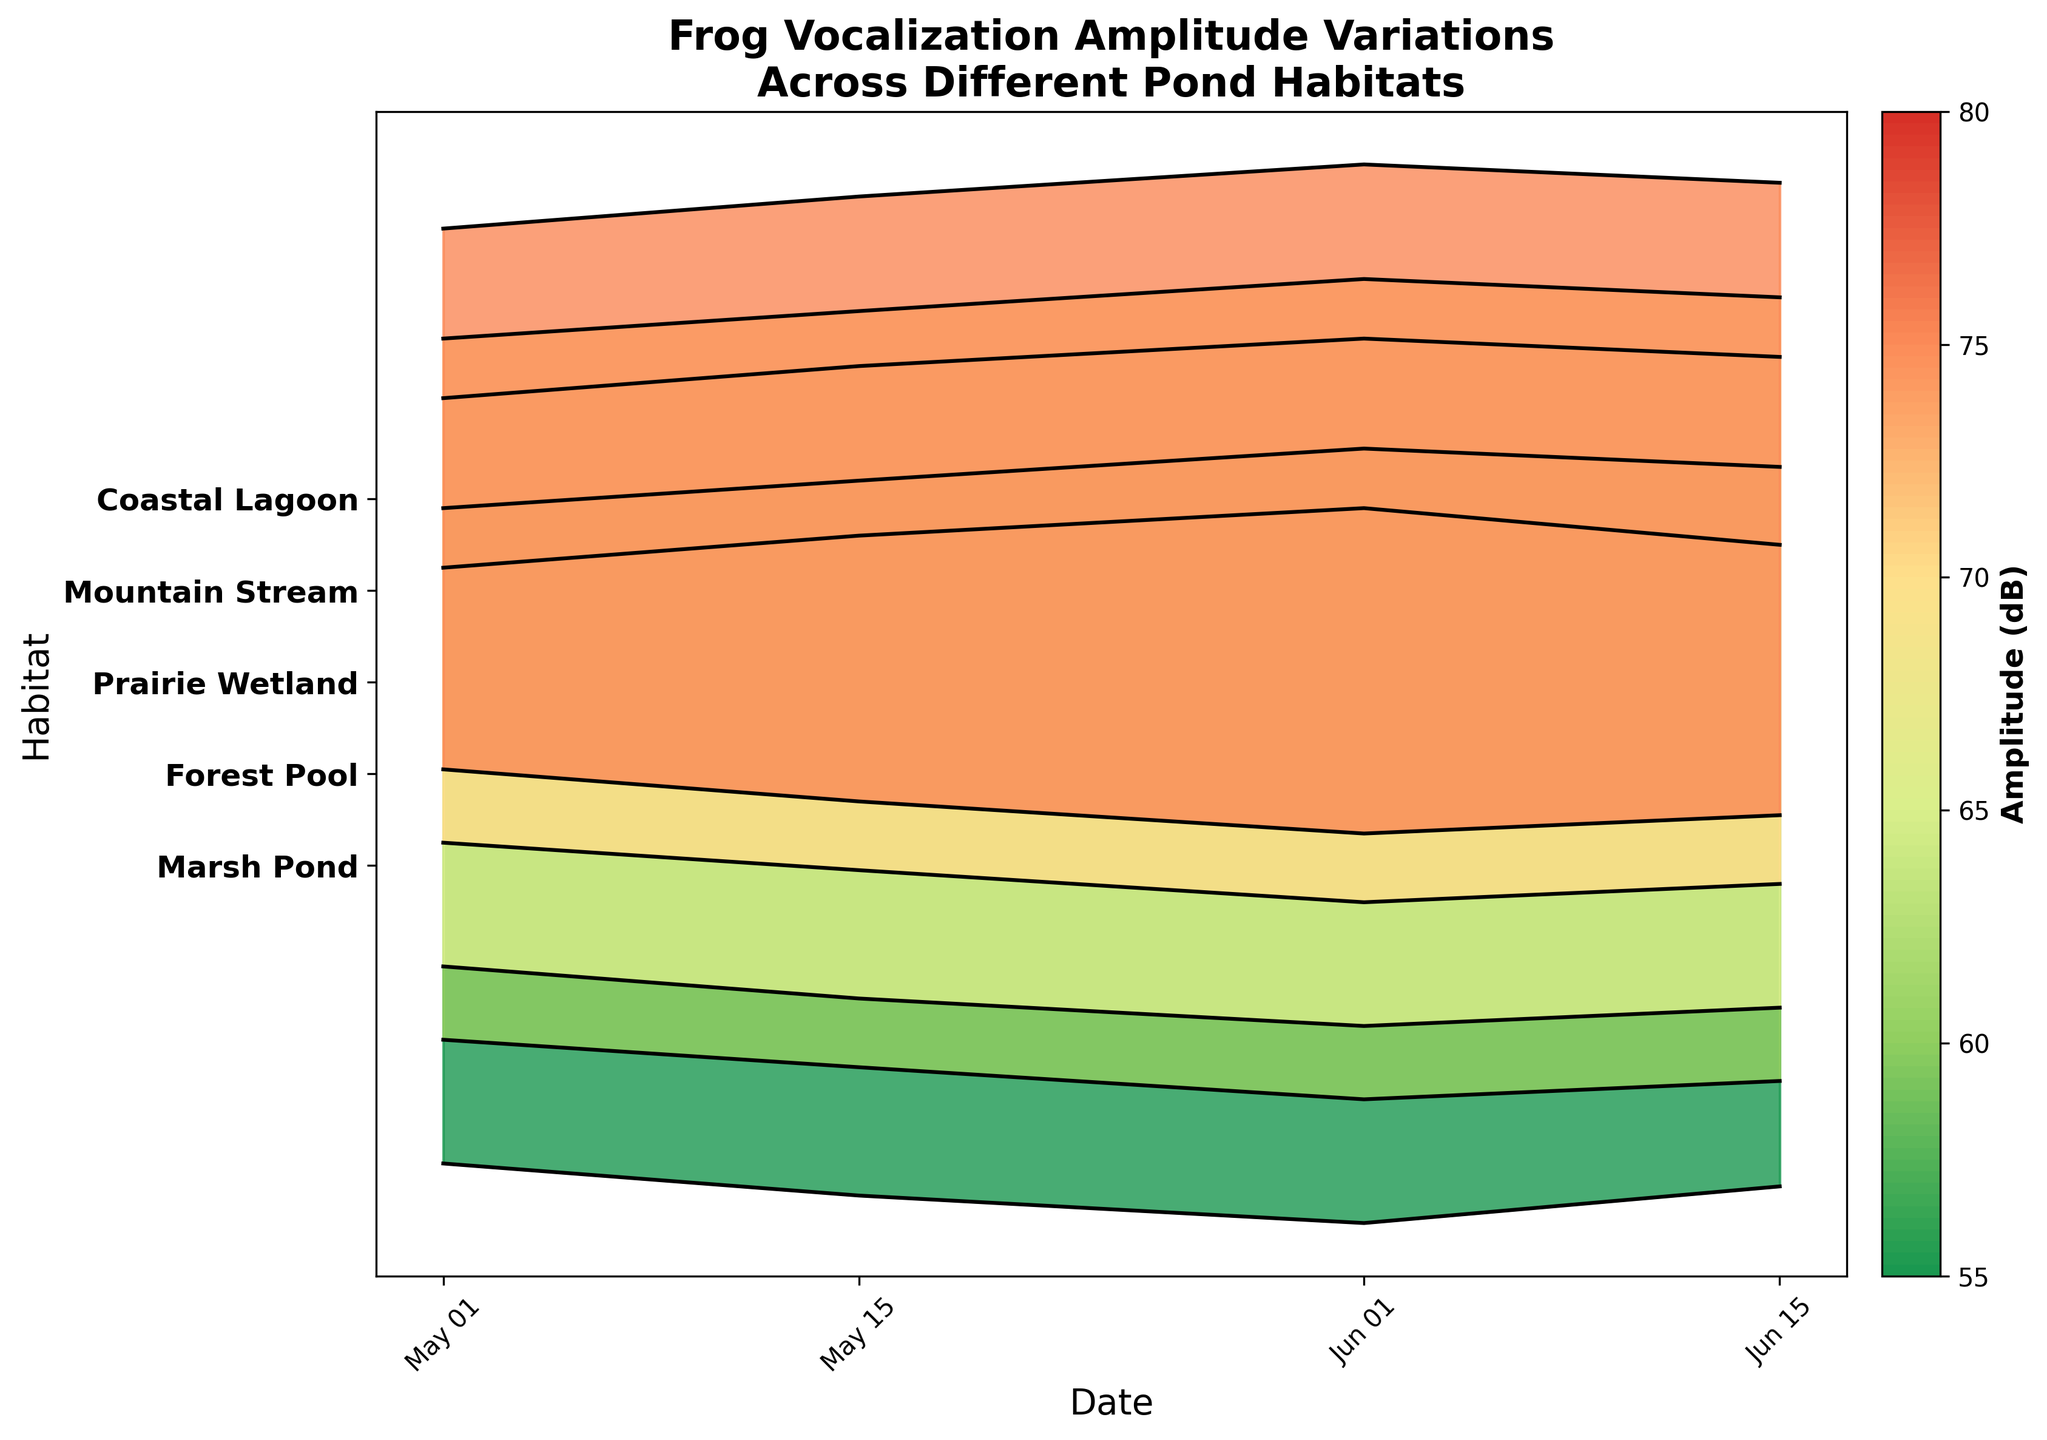Which habitat shows the highest amplitude on June 1st? To determine the habitat with the highest amplitude on June 1st, observe the peak values within the ridgeline plots for each habitat on that date. Compare the heights of the peaks visually, and identify the habitat with the highest peak value.
Answer: Marsh Pond Which species shows the most significant increase in amplitude from May 1st to June 1st? Calculate the difference in amplitude values from May 1st to June 1st for each species. Compare these differences to determine which species exhibits the largest increase. For example, the American Bullfrog's amplitude increases from 65 dB to 78 dB, a difference of 13 dB.
Answer: American Bullfrog What is the range of amplitudes observed for the Green Frog? To find the range of amplitudes for the Green Frog in the Coastal Lagoon, note the maximum and minimum amplitude values. The maximum amplitude is 73 dB (June 1st) and the minimum is 59 dB (May 1st), yielding a range of 73 - 59 = 14 dB.
Answer: 14 dB Which frog species shows the least variation in amplitude over the observed dates? Evaluate the amplitude variation for each species by identifying the range (difference between maximum and minimum amplitudes) for each. The species with the smallest range indicates the least variation.
Answer: Pacific Chorus Frog How do the amplitude trends for Gray Treefrog and Northern Leopard Frog compare over time? Compare the ridgeline plots for these two species. Note how the amplitude values change for Gray Treefrog in the Forest Pool and Northern Leopard Frog in the Prairie Wetland from May 1st to June 15th. Gray Treefrog shows a steady increase in amplitude, while Northern Leopard Frog also increases, though with a slightly higher overall amplitude.
Answer: Both increase, but Northern Leopard Frog has slightly higher amplitudes What is the average amplitude for the Pacific Chorus Frog on all observed dates? Calculate the average (mean) of the amplitudes recorded for the Pacific Chorus Frog. Sum the amplitude values (55 + 61 + 68 + 64) and divide by the number of observations (4). (55 + 61 + 68 + 64) / 4 = 62 dB.
Answer: 62 dB Which habitat has the most consistent amplitude over time? Assess the variation in amplitude over time for each habitat by visually inspecting the heights and overlaps of the ridgeline plots. The habitat with the least variation (less spread between the ridgelines over time) indicates consistency.
Answer: Mountain Stream Which date shows the highest overall amplitudes across all habitats? Observe the dates on the x-axis and compare the heights of the ridgelines across all habitats for each date. The date where most ridgelines peak at higher values will have the highest overall amplitudes.
Answer: June 1st What is the difference in amplitude between Marsh Pond and Coastal Lagoon on May 15th? Identify the amplitude values for Marsh Pond (American Bullfrog) and Coastal Lagoon (Green Frog) on May 15th. Marsh Pond is at 72 dB and Coastal Lagoon is at 66 dB, so the difference is 72 - 66 = 6 dB.
Answer: 6 dB 